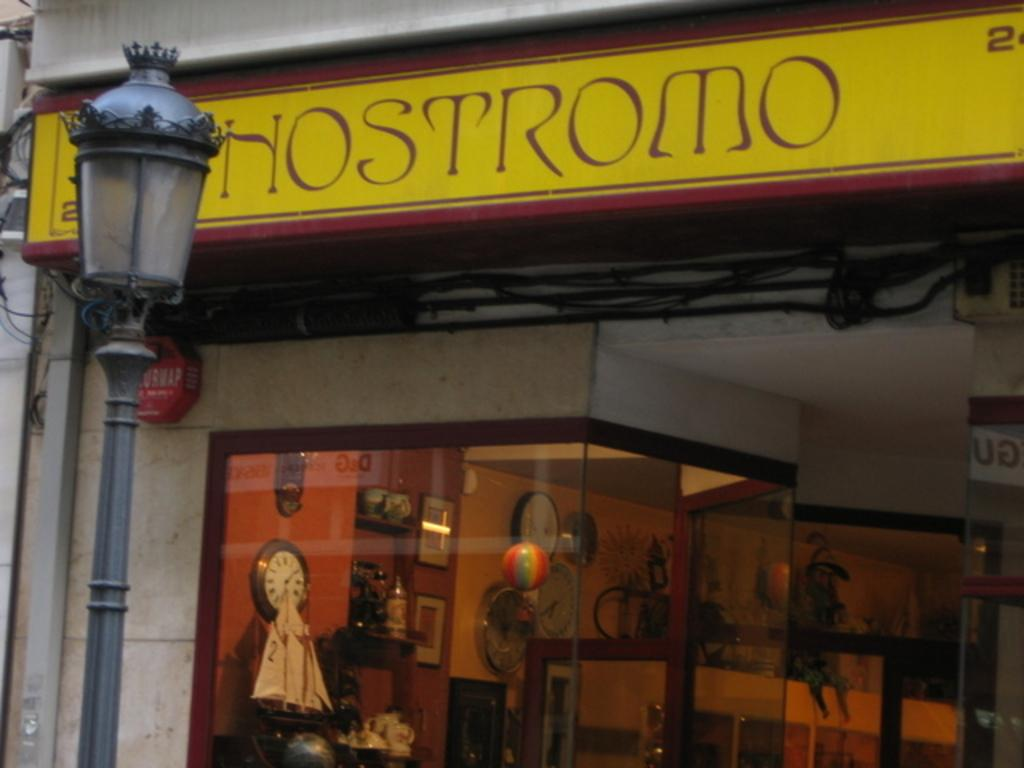<image>
Share a concise interpretation of the image provided. A yellow sign above a store that says "Hostromo". 